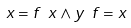<formula> <loc_0><loc_0><loc_500><loc_500>x = f \ x \land y \ f = x</formula> 